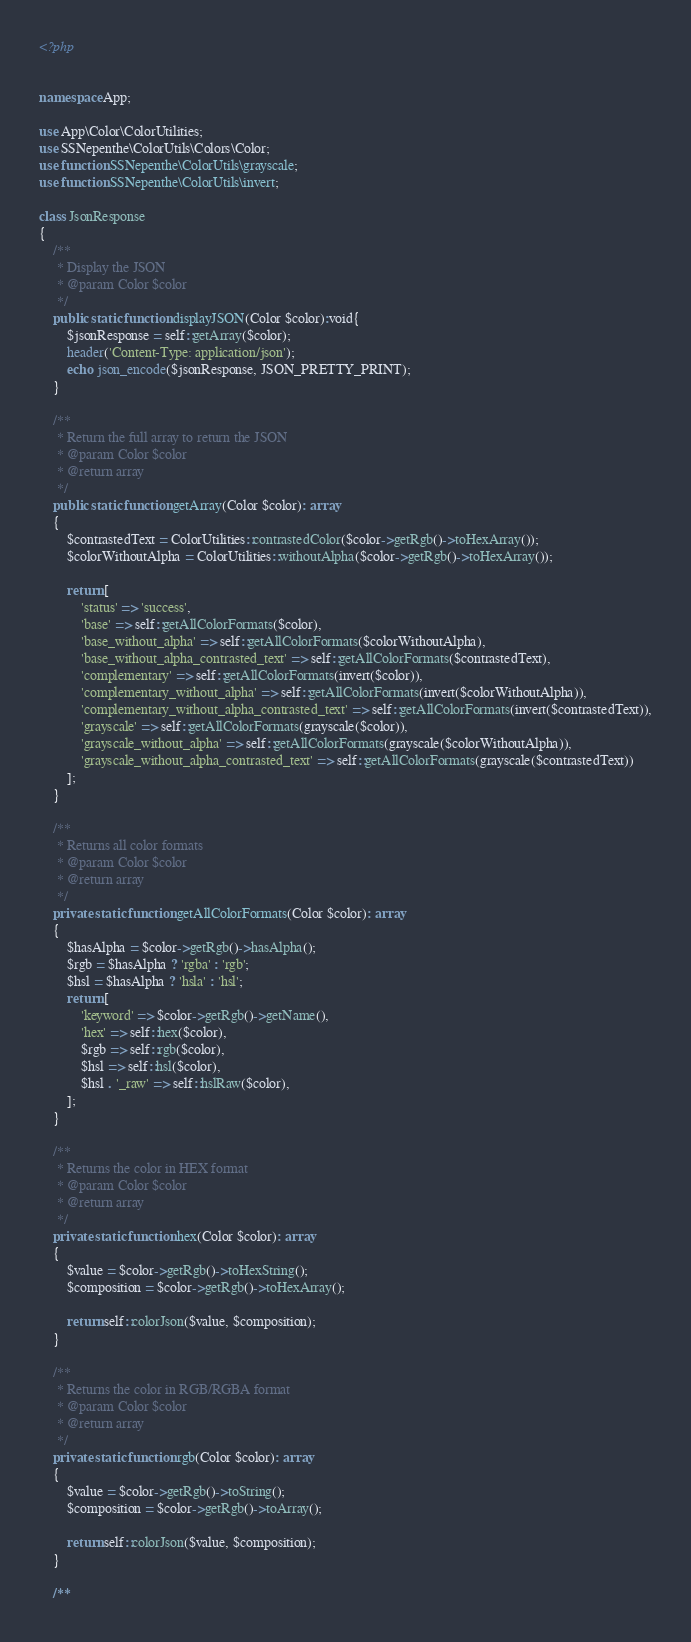<code> <loc_0><loc_0><loc_500><loc_500><_PHP_><?php


namespace App;

use App\Color\ColorUtilities;
use SSNepenthe\ColorUtils\Colors\Color;
use function SSNepenthe\ColorUtils\grayscale;
use function SSNepenthe\ColorUtils\invert;

class JsonResponse
{
    /**
     * Display the JSON
     * @param Color $color
     */
    public static function displayJSON(Color $color):void{
        $jsonResponse = self::getArray($color);
        header('Content-Type: application/json');
        echo json_encode($jsonResponse, JSON_PRETTY_PRINT);
    }

    /**
     * Return the full array to return the JSON
     * @param Color $color
     * @return array
     */
    public static function getArray(Color $color): array
    {
        $contrastedText = ColorUtilities::contrastedColor($color->getRgb()->toHexArray());
        $colorWithoutAlpha = ColorUtilities::withoutAlpha($color->getRgb()->toHexArray());

        return [
            'status' => 'success',
            'base' => self::getAllColorFormats($color),
            'base_without_alpha' => self::getAllColorFormats($colorWithoutAlpha),
            'base_without_alpha_contrasted_text' => self::getAllColorFormats($contrastedText),
            'complementary' => self::getAllColorFormats(invert($color)),
            'complementary_without_alpha' => self::getAllColorFormats(invert($colorWithoutAlpha)),
            'complementary_without_alpha_contrasted_text' => self::getAllColorFormats(invert($contrastedText)),
            'grayscale' => self::getAllColorFormats(grayscale($color)),
            'grayscale_without_alpha' => self::getAllColorFormats(grayscale($colorWithoutAlpha)),
            'grayscale_without_alpha_contrasted_text' => self::getAllColorFormats(grayscale($contrastedText))
        ];
    }

    /**
     * Returns all color formats
     * @param Color $color
     * @return array
     */
    private static function getAllColorFormats(Color $color): array
    {
        $hasAlpha = $color->getRgb()->hasAlpha();
        $rgb = $hasAlpha ? 'rgba' : 'rgb';
        $hsl = $hasAlpha ? 'hsla' : 'hsl';
        return [
            'keyword' => $color->getRgb()->getName(),
            'hex' => self::hex($color),
            $rgb => self::rgb($color),
            $hsl => self::hsl($color),
            $hsl . '_raw' => self::hslRaw($color),
        ];
    }

    /**
     * Returns the color in HEX format
     * @param Color $color
     * @return array
     */
    private static function hex(Color $color): array
    {
        $value = $color->getRgb()->toHexString();
        $composition = $color->getRgb()->toHexArray();

        return self::colorJson($value, $composition);
    }

    /**
     * Returns the color in RGB/RGBA format
     * @param Color $color
     * @return array
     */
    private static function rgb(Color $color): array
    {
        $value = $color->getRgb()->toString();
        $composition = $color->getRgb()->toArray();

        return self::colorJson($value, $composition);
    }

    /**</code> 